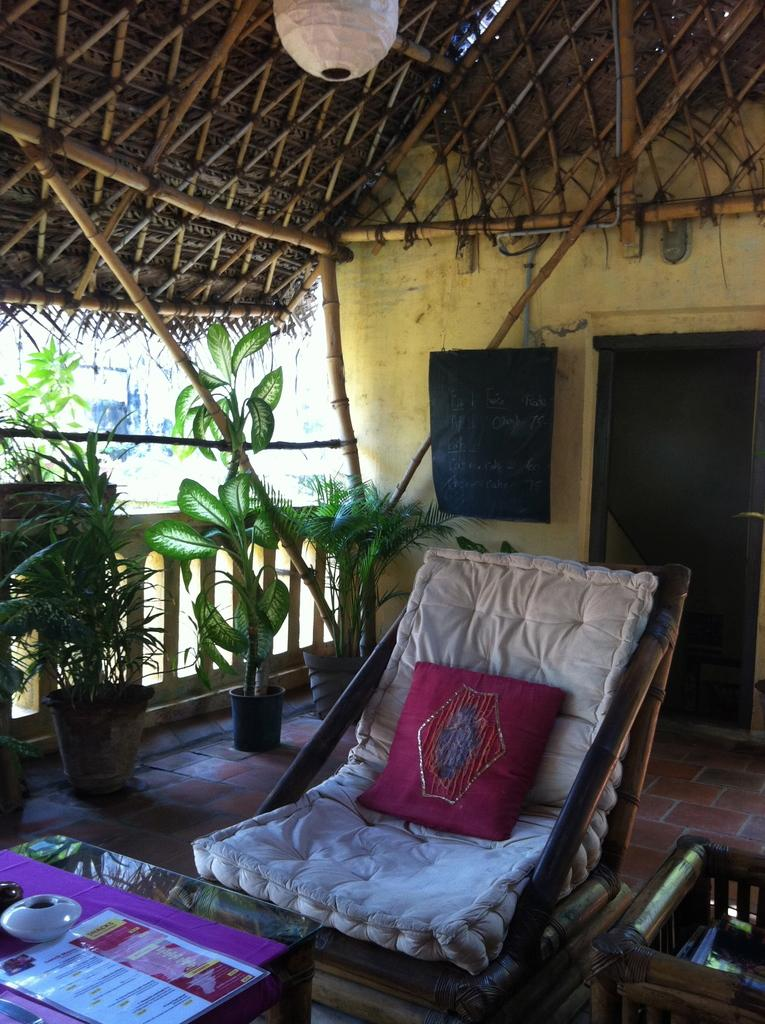What type of furniture is in the image? There is a chair in the image. What is on the chair? The chair has a cushion on it. What type of vegetation is in the image? There are plants in a pot in the image. What is on the wall in the image? There is a blackboard on the wall in the image. How many actors are visible in the image? There are no actors present in the image. What color are the eyes of the bear in the image? There are no bears or eyes visible in the image. 